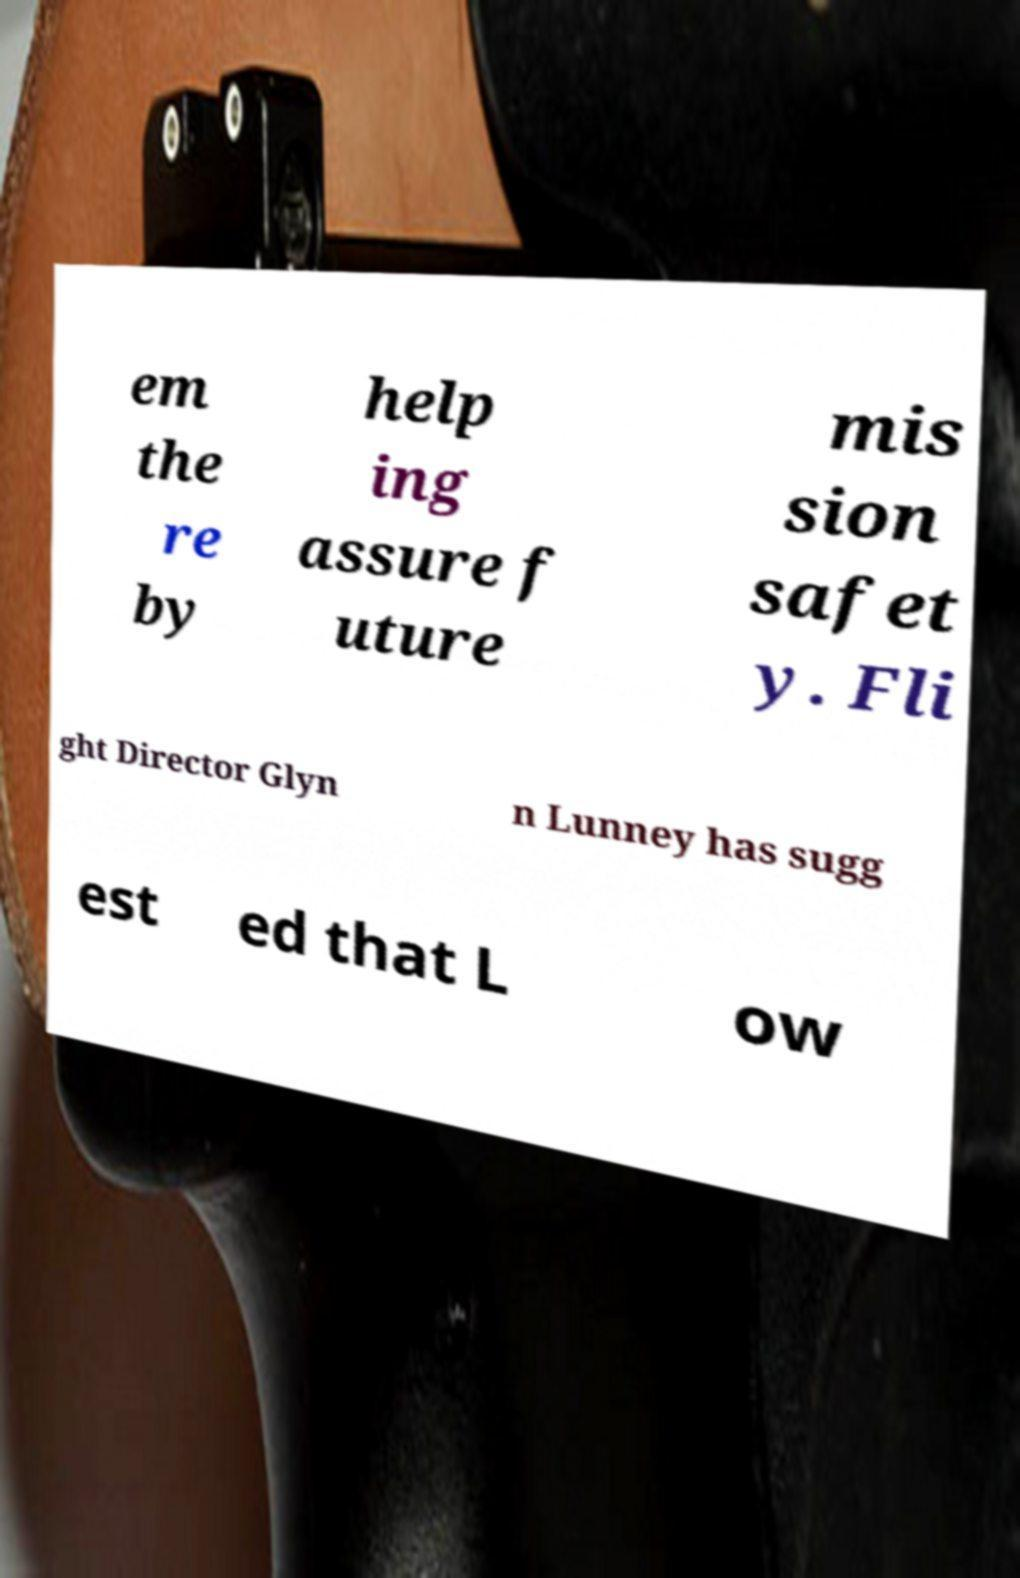Can you accurately transcribe the text from the provided image for me? em the re by help ing assure f uture mis sion safet y. Fli ght Director Glyn n Lunney has sugg est ed that L ow 